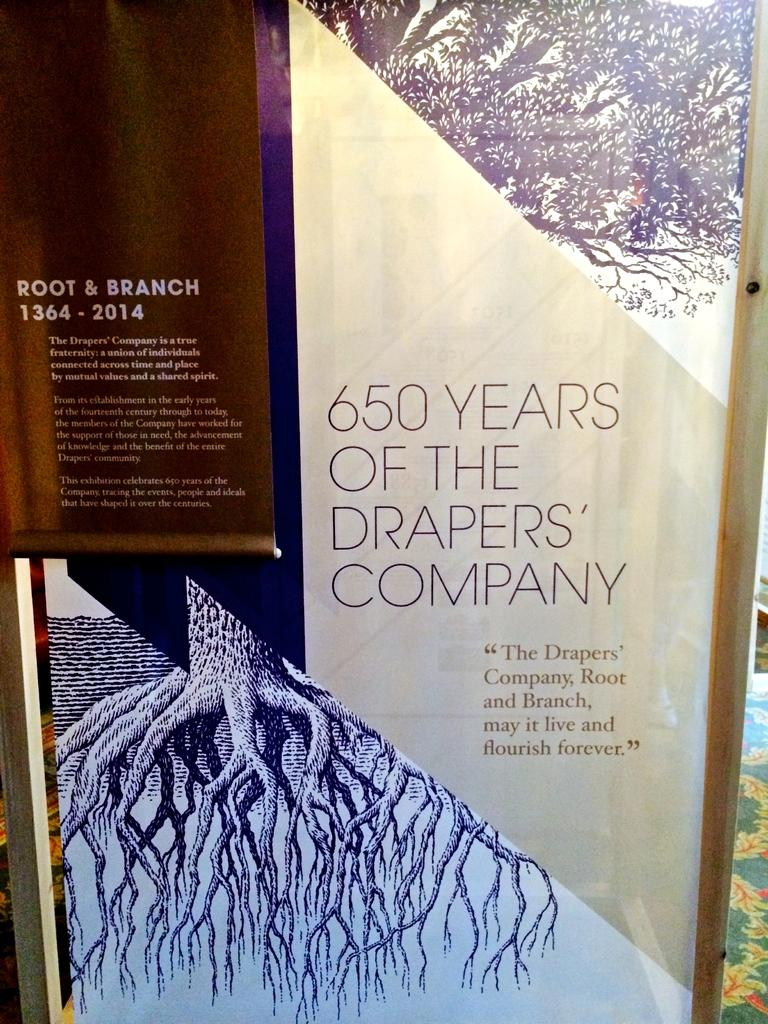<image>
Relay a brief, clear account of the picture shown. Sign that says 650 years of the Draper's Company in a room. 